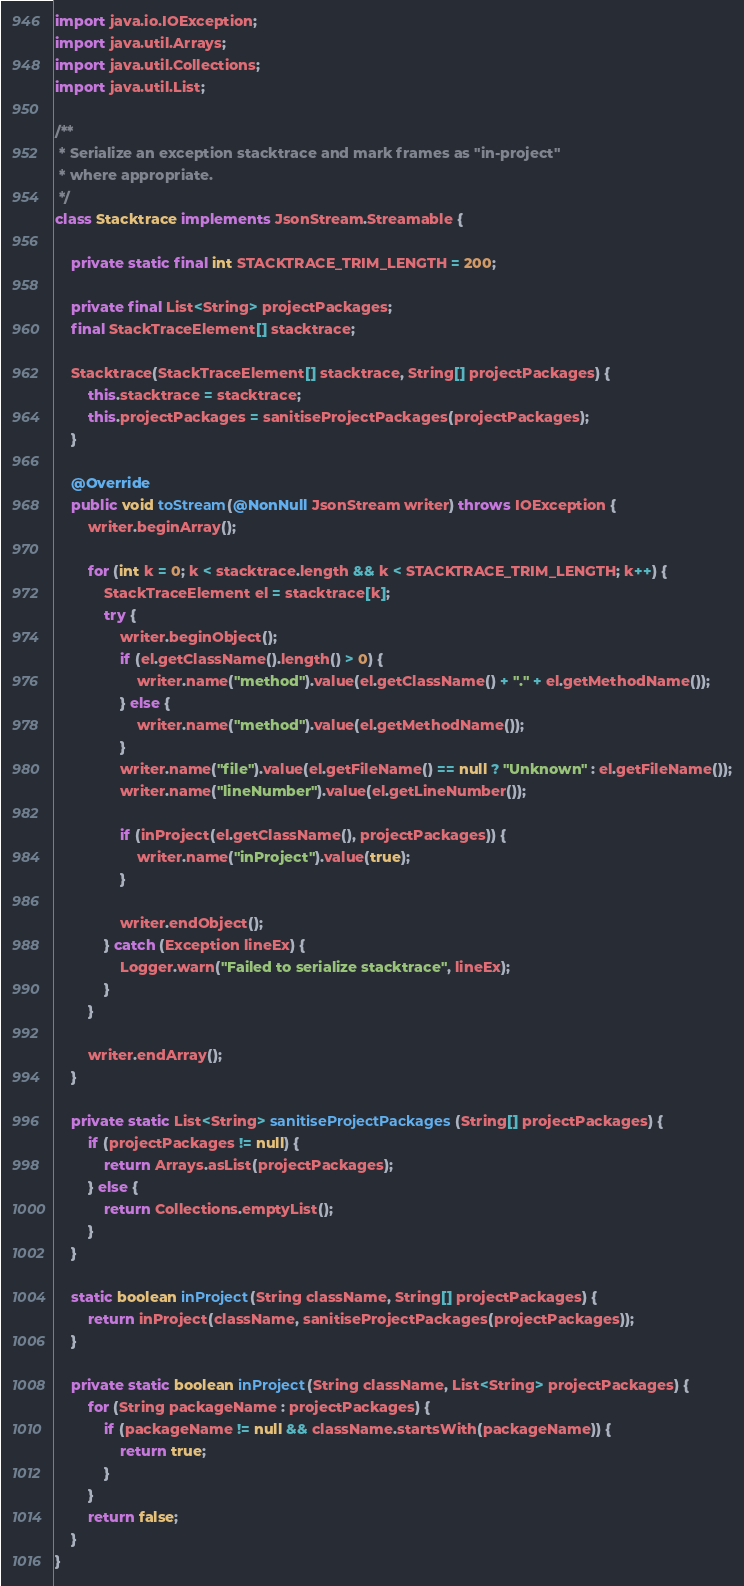<code> <loc_0><loc_0><loc_500><loc_500><_Java_>
import java.io.IOException;
import java.util.Arrays;
import java.util.Collections;
import java.util.List;

/**
 * Serialize an exception stacktrace and mark frames as "in-project"
 * where appropriate.
 */
class Stacktrace implements JsonStream.Streamable {

    private static final int STACKTRACE_TRIM_LENGTH = 200;

    private final List<String> projectPackages;
    final StackTraceElement[] stacktrace;

    Stacktrace(StackTraceElement[] stacktrace, String[] projectPackages) {
        this.stacktrace = stacktrace;
        this.projectPackages = sanitiseProjectPackages(projectPackages);
    }

    @Override
    public void toStream(@NonNull JsonStream writer) throws IOException {
        writer.beginArray();

        for (int k = 0; k < stacktrace.length && k < STACKTRACE_TRIM_LENGTH; k++) {
            StackTraceElement el = stacktrace[k];
            try {
                writer.beginObject();
                if (el.getClassName().length() > 0) {
                    writer.name("method").value(el.getClassName() + "." + el.getMethodName());
                } else {
                    writer.name("method").value(el.getMethodName());
                }
                writer.name("file").value(el.getFileName() == null ? "Unknown" : el.getFileName());
                writer.name("lineNumber").value(el.getLineNumber());

                if (inProject(el.getClassName(), projectPackages)) {
                    writer.name("inProject").value(true);
                }

                writer.endObject();
            } catch (Exception lineEx) {
                Logger.warn("Failed to serialize stacktrace", lineEx);
            }
        }

        writer.endArray();
    }

    private static List<String> sanitiseProjectPackages(String[] projectPackages) {
        if (projectPackages != null) {
            return Arrays.asList(projectPackages);
        } else {
            return Collections.emptyList();
        }
    }

    static boolean inProject(String className, String[] projectPackages) {
        return inProject(className, sanitiseProjectPackages(projectPackages));
    }

    private static boolean inProject(String className, List<String> projectPackages) {
        for (String packageName : projectPackages) {
            if (packageName != null && className.startsWith(packageName)) {
                return true;
            }
        }
        return false;
    }
}
</code> 